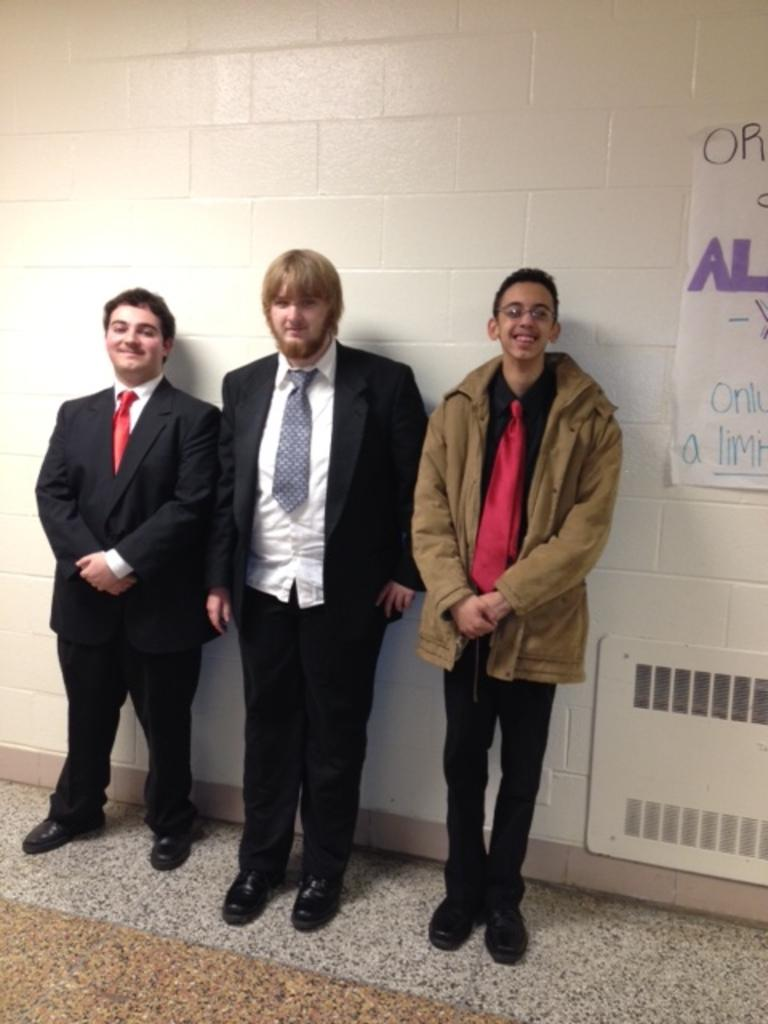How many men are in the image? There are three men in the image. What type of clothing are the men wearing on their upper bodies? Each man is wearing a blazer and a tie. What type of footwear are the men wearing? Each man is wearing shoes. What are the men doing in the image? The men are standing. What can be seen in the background of the image? There is a wall and a poster in the background of the image. How many sheep are visible in the image? There are no sheep present in the image. What type of bird is sitting on the shoulder of one of the men in the image? There are no birds visible in the image. 